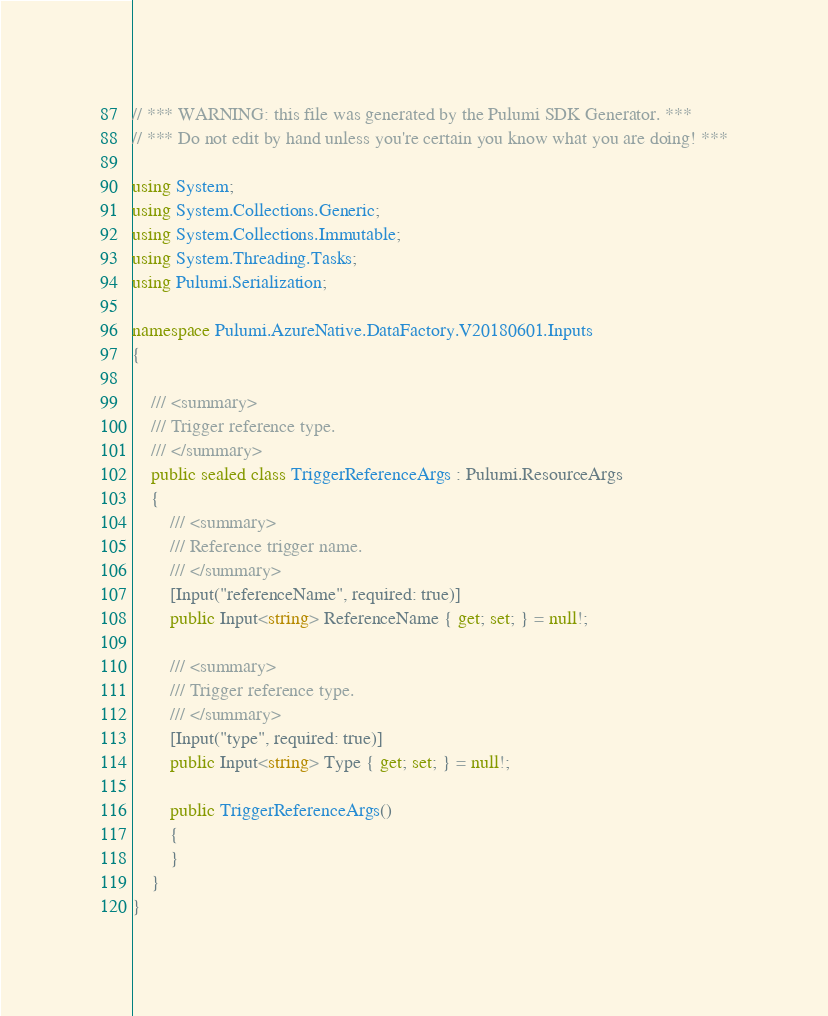Convert code to text. <code><loc_0><loc_0><loc_500><loc_500><_C#_>// *** WARNING: this file was generated by the Pulumi SDK Generator. ***
// *** Do not edit by hand unless you're certain you know what you are doing! ***

using System;
using System.Collections.Generic;
using System.Collections.Immutable;
using System.Threading.Tasks;
using Pulumi.Serialization;

namespace Pulumi.AzureNative.DataFactory.V20180601.Inputs
{

    /// <summary>
    /// Trigger reference type.
    /// </summary>
    public sealed class TriggerReferenceArgs : Pulumi.ResourceArgs
    {
        /// <summary>
        /// Reference trigger name.
        /// </summary>
        [Input("referenceName", required: true)]
        public Input<string> ReferenceName { get; set; } = null!;

        /// <summary>
        /// Trigger reference type.
        /// </summary>
        [Input("type", required: true)]
        public Input<string> Type { get; set; } = null!;

        public TriggerReferenceArgs()
        {
        }
    }
}
</code> 